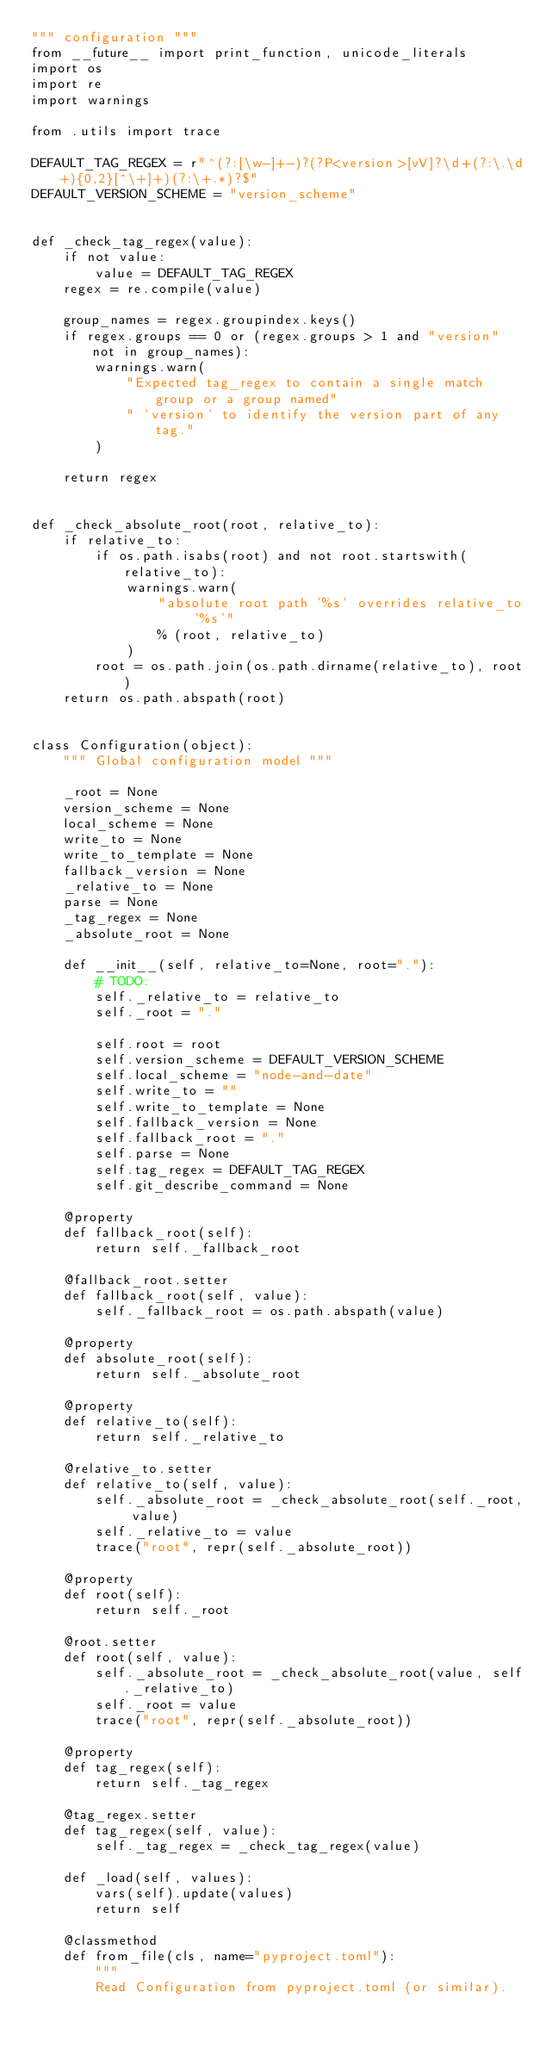<code> <loc_0><loc_0><loc_500><loc_500><_Python_>""" configuration """
from __future__ import print_function, unicode_literals
import os
import re
import warnings

from .utils import trace

DEFAULT_TAG_REGEX = r"^(?:[\w-]+-)?(?P<version>[vV]?\d+(?:\.\d+){0,2}[^\+]+)(?:\+.*)?$"
DEFAULT_VERSION_SCHEME = "version_scheme"


def _check_tag_regex(value):
    if not value:
        value = DEFAULT_TAG_REGEX
    regex = re.compile(value)

    group_names = regex.groupindex.keys()
    if regex.groups == 0 or (regex.groups > 1 and "version" not in group_names):
        warnings.warn(
            "Expected tag_regex to contain a single match group or a group named"
            " 'version' to identify the version part of any tag."
        )

    return regex


def _check_absolute_root(root, relative_to):
    if relative_to:
        if os.path.isabs(root) and not root.startswith(relative_to):
            warnings.warn(
                "absolute root path '%s' overrides relative_to '%s'"
                % (root, relative_to)
            )
        root = os.path.join(os.path.dirname(relative_to), root)
    return os.path.abspath(root)


class Configuration(object):
    """ Global configuration model """

    _root = None
    version_scheme = None
    local_scheme = None
    write_to = None
    write_to_template = None
    fallback_version = None
    _relative_to = None
    parse = None
    _tag_regex = None
    _absolute_root = None

    def __init__(self, relative_to=None, root="."):
        # TODO:
        self._relative_to = relative_to
        self._root = "."

        self.root = root
        self.version_scheme = DEFAULT_VERSION_SCHEME
        self.local_scheme = "node-and-date"
        self.write_to = ""
        self.write_to_template = None
        self.fallback_version = None
        self.fallback_root = "."
        self.parse = None
        self.tag_regex = DEFAULT_TAG_REGEX
        self.git_describe_command = None

    @property
    def fallback_root(self):
        return self._fallback_root

    @fallback_root.setter
    def fallback_root(self, value):
        self._fallback_root = os.path.abspath(value)

    @property
    def absolute_root(self):
        return self._absolute_root

    @property
    def relative_to(self):
        return self._relative_to

    @relative_to.setter
    def relative_to(self, value):
        self._absolute_root = _check_absolute_root(self._root, value)
        self._relative_to = value
        trace("root", repr(self._absolute_root))

    @property
    def root(self):
        return self._root

    @root.setter
    def root(self, value):
        self._absolute_root = _check_absolute_root(value, self._relative_to)
        self._root = value
        trace("root", repr(self._absolute_root))

    @property
    def tag_regex(self):
        return self._tag_regex

    @tag_regex.setter
    def tag_regex(self, value):
        self._tag_regex = _check_tag_regex(value)

    def _load(self, values):
        vars(self).update(values)
        return self

    @classmethod
    def from_file(cls, name="pyproject.toml"):
        """
        Read Configuration from pyproject.toml (or similar).</code> 